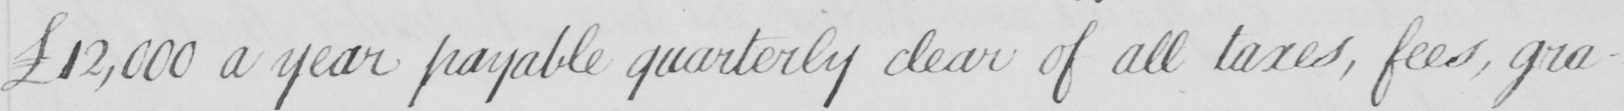Please provide the text content of this handwritten line. £12,000 a year payable quarterly clear of all taxes , fees , gra- 